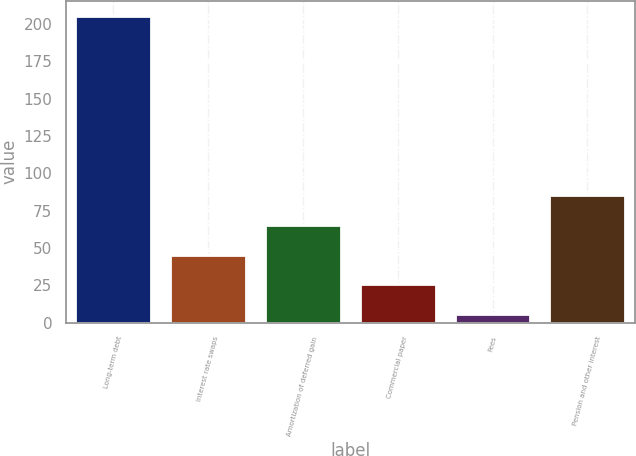Convert chart to OTSL. <chart><loc_0><loc_0><loc_500><loc_500><bar_chart><fcel>Long-term debt<fcel>Interest rate swaps<fcel>Amortization of deferred gain<fcel>Commercial paper<fcel>Fees<fcel>Pension and other interest<nl><fcel>205.5<fcel>45.58<fcel>65.57<fcel>25.59<fcel>5.6<fcel>85.56<nl></chart> 